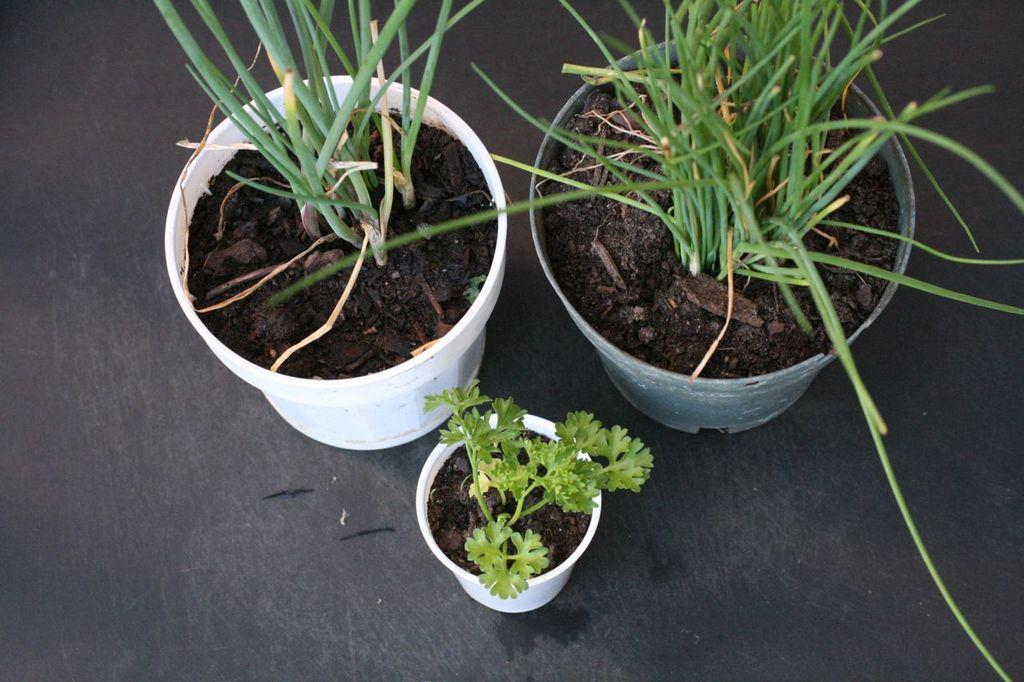What can be seen in the image related to plants? There are three pots with mud and plants in the image. Where are the pots located? The pots are on the floor. What else can be seen near the pots on the floor? There are small objects near the pots on the floor. How does the anger of the mom affect the cushion in the image? There is no mention of anger, mom, or a cushion in the image, so this question cannot be answered. 